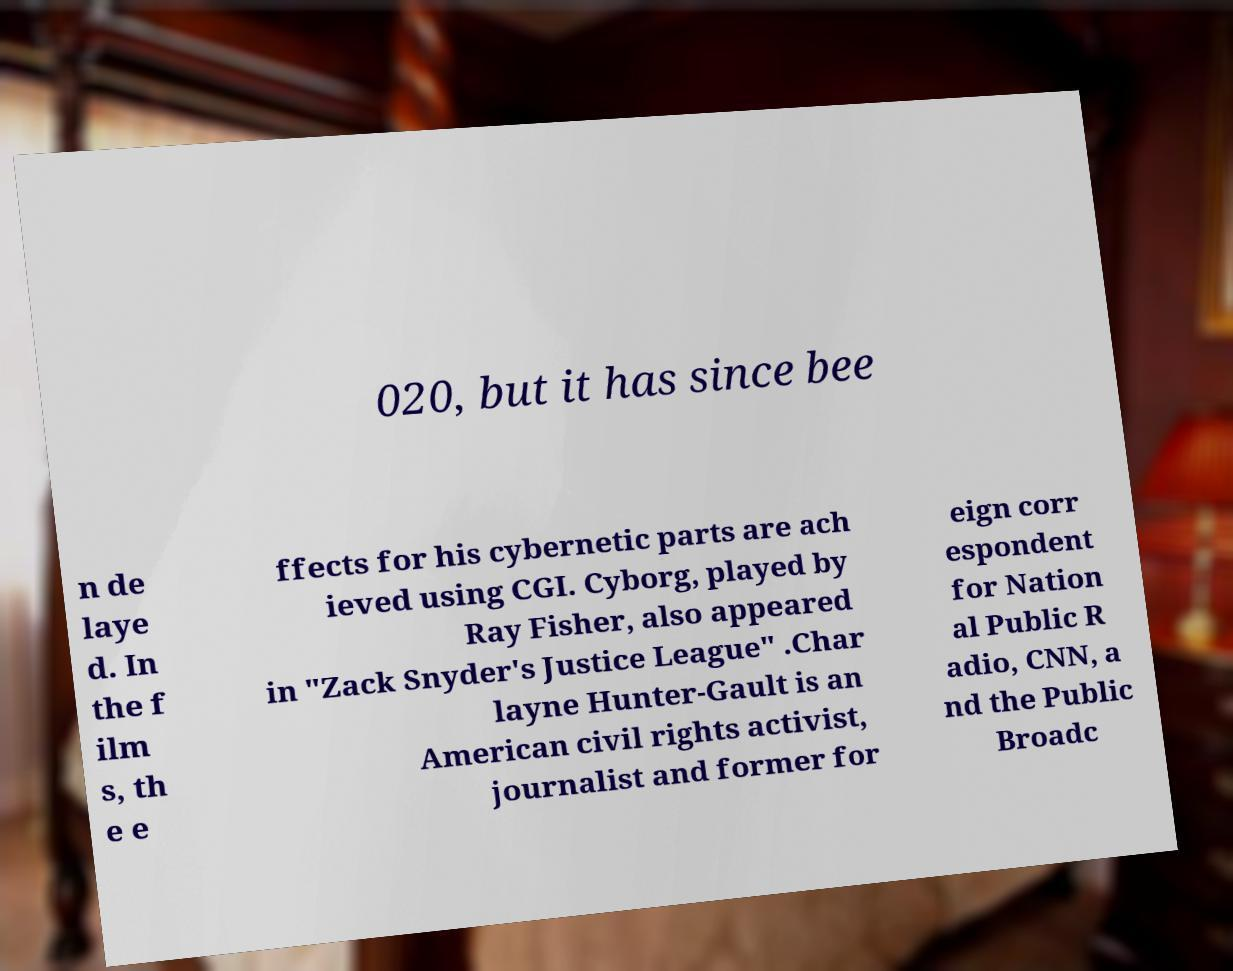Could you assist in decoding the text presented in this image and type it out clearly? 020, but it has since bee n de laye d. In the f ilm s, th e e ffects for his cybernetic parts are ach ieved using CGI. Cyborg, played by Ray Fisher, also appeared in "Zack Snyder's Justice League" .Char layne Hunter-Gault is an American civil rights activist, journalist and former for eign corr espondent for Nation al Public R adio, CNN, a nd the Public Broadc 